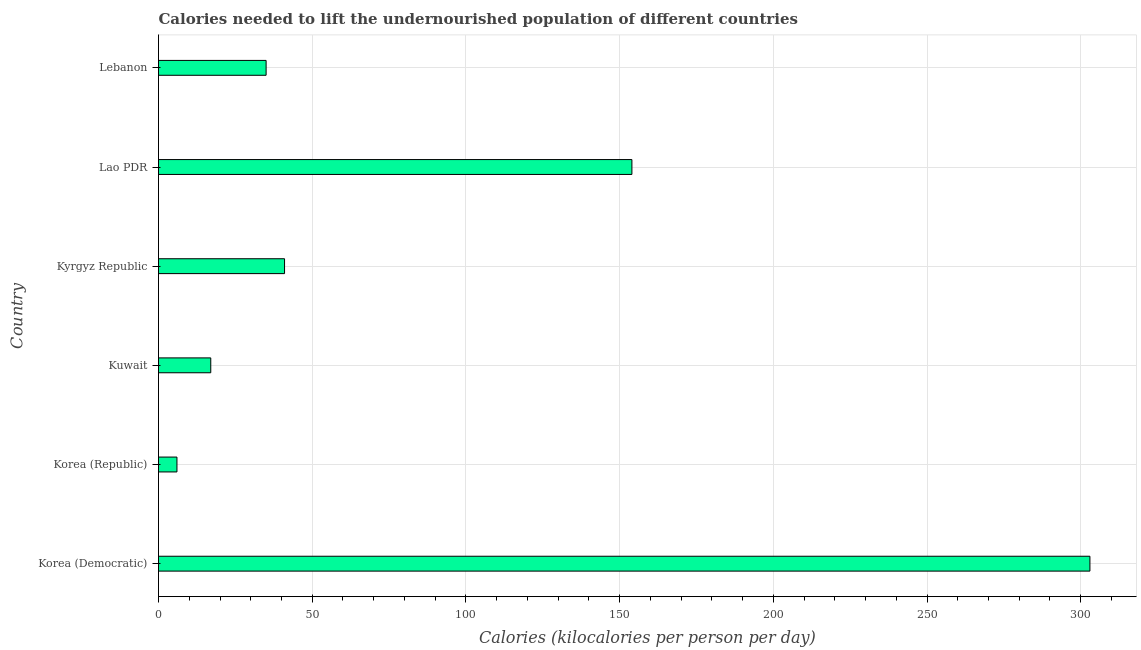Does the graph contain grids?
Make the answer very short. Yes. What is the title of the graph?
Give a very brief answer. Calories needed to lift the undernourished population of different countries. What is the label or title of the X-axis?
Ensure brevity in your answer.  Calories (kilocalories per person per day). Across all countries, what is the maximum depth of food deficit?
Your answer should be compact. 303. Across all countries, what is the minimum depth of food deficit?
Provide a succinct answer. 6. In which country was the depth of food deficit maximum?
Ensure brevity in your answer.  Korea (Democratic). In which country was the depth of food deficit minimum?
Your response must be concise. Korea (Republic). What is the sum of the depth of food deficit?
Your answer should be very brief. 556. What is the difference between the depth of food deficit in Korea (Democratic) and Kyrgyz Republic?
Provide a short and direct response. 262. What is the average depth of food deficit per country?
Provide a succinct answer. 92.67. What is the median depth of food deficit?
Give a very brief answer. 38. What is the ratio of the depth of food deficit in Korea (Democratic) to that in Kuwait?
Make the answer very short. 17.82. What is the difference between the highest and the second highest depth of food deficit?
Make the answer very short. 149. What is the difference between the highest and the lowest depth of food deficit?
Keep it short and to the point. 297. In how many countries, is the depth of food deficit greater than the average depth of food deficit taken over all countries?
Ensure brevity in your answer.  2. How many bars are there?
Provide a succinct answer. 6. Are all the bars in the graph horizontal?
Provide a succinct answer. Yes. How many countries are there in the graph?
Your answer should be compact. 6. What is the Calories (kilocalories per person per day) in Korea (Democratic)?
Your response must be concise. 303. What is the Calories (kilocalories per person per day) of Lao PDR?
Keep it short and to the point. 154. What is the difference between the Calories (kilocalories per person per day) in Korea (Democratic) and Korea (Republic)?
Make the answer very short. 297. What is the difference between the Calories (kilocalories per person per day) in Korea (Democratic) and Kuwait?
Ensure brevity in your answer.  286. What is the difference between the Calories (kilocalories per person per day) in Korea (Democratic) and Kyrgyz Republic?
Make the answer very short. 262. What is the difference between the Calories (kilocalories per person per day) in Korea (Democratic) and Lao PDR?
Keep it short and to the point. 149. What is the difference between the Calories (kilocalories per person per day) in Korea (Democratic) and Lebanon?
Provide a short and direct response. 268. What is the difference between the Calories (kilocalories per person per day) in Korea (Republic) and Kyrgyz Republic?
Offer a very short reply. -35. What is the difference between the Calories (kilocalories per person per day) in Korea (Republic) and Lao PDR?
Offer a terse response. -148. What is the difference between the Calories (kilocalories per person per day) in Korea (Republic) and Lebanon?
Make the answer very short. -29. What is the difference between the Calories (kilocalories per person per day) in Kuwait and Kyrgyz Republic?
Keep it short and to the point. -24. What is the difference between the Calories (kilocalories per person per day) in Kuwait and Lao PDR?
Your answer should be very brief. -137. What is the difference between the Calories (kilocalories per person per day) in Kuwait and Lebanon?
Provide a succinct answer. -18. What is the difference between the Calories (kilocalories per person per day) in Kyrgyz Republic and Lao PDR?
Give a very brief answer. -113. What is the difference between the Calories (kilocalories per person per day) in Lao PDR and Lebanon?
Ensure brevity in your answer.  119. What is the ratio of the Calories (kilocalories per person per day) in Korea (Democratic) to that in Korea (Republic)?
Your response must be concise. 50.5. What is the ratio of the Calories (kilocalories per person per day) in Korea (Democratic) to that in Kuwait?
Give a very brief answer. 17.82. What is the ratio of the Calories (kilocalories per person per day) in Korea (Democratic) to that in Kyrgyz Republic?
Offer a very short reply. 7.39. What is the ratio of the Calories (kilocalories per person per day) in Korea (Democratic) to that in Lao PDR?
Your answer should be very brief. 1.97. What is the ratio of the Calories (kilocalories per person per day) in Korea (Democratic) to that in Lebanon?
Give a very brief answer. 8.66. What is the ratio of the Calories (kilocalories per person per day) in Korea (Republic) to that in Kuwait?
Your answer should be very brief. 0.35. What is the ratio of the Calories (kilocalories per person per day) in Korea (Republic) to that in Kyrgyz Republic?
Provide a short and direct response. 0.15. What is the ratio of the Calories (kilocalories per person per day) in Korea (Republic) to that in Lao PDR?
Provide a succinct answer. 0.04. What is the ratio of the Calories (kilocalories per person per day) in Korea (Republic) to that in Lebanon?
Your answer should be very brief. 0.17. What is the ratio of the Calories (kilocalories per person per day) in Kuwait to that in Kyrgyz Republic?
Provide a succinct answer. 0.41. What is the ratio of the Calories (kilocalories per person per day) in Kuwait to that in Lao PDR?
Give a very brief answer. 0.11. What is the ratio of the Calories (kilocalories per person per day) in Kuwait to that in Lebanon?
Offer a very short reply. 0.49. What is the ratio of the Calories (kilocalories per person per day) in Kyrgyz Republic to that in Lao PDR?
Give a very brief answer. 0.27. What is the ratio of the Calories (kilocalories per person per day) in Kyrgyz Republic to that in Lebanon?
Provide a short and direct response. 1.17. 